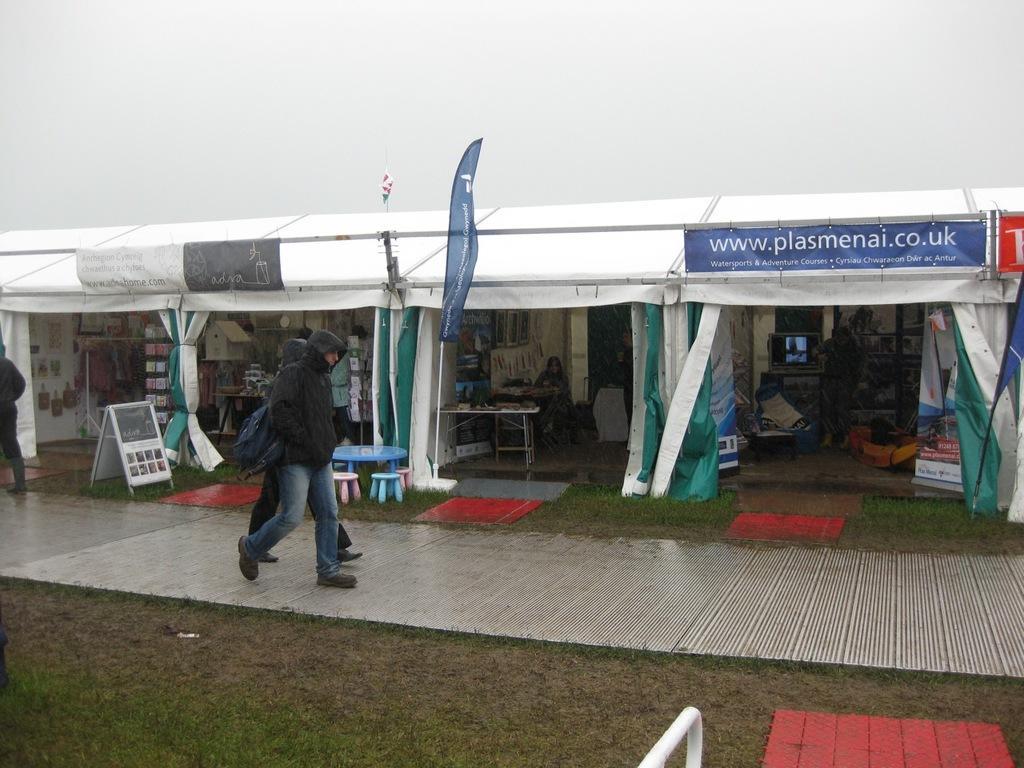How would you summarize this image in a sentence or two? In this image we can see the stalls with some objects, there are some banners, flags and some other objects, also we can see a few people, among them two persons are walking in front of the stalls. 